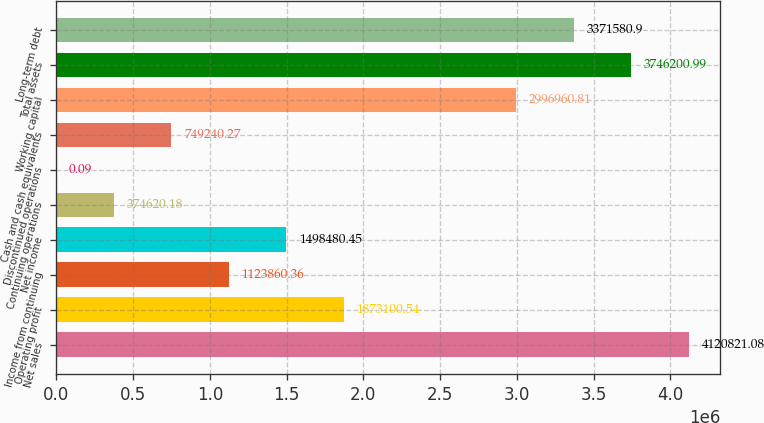Convert chart to OTSL. <chart><loc_0><loc_0><loc_500><loc_500><bar_chart><fcel>Net sales<fcel>Operating profit<fcel>Income from continuing<fcel>Net income<fcel>Continuing operations<fcel>Discontinued operations<fcel>Cash and cash equivalents<fcel>Working capital<fcel>Total assets<fcel>Long-term debt<nl><fcel>4.12082e+06<fcel>1.8731e+06<fcel>1.12386e+06<fcel>1.49848e+06<fcel>374620<fcel>0.09<fcel>749240<fcel>2.99696e+06<fcel>3.7462e+06<fcel>3.37158e+06<nl></chart> 